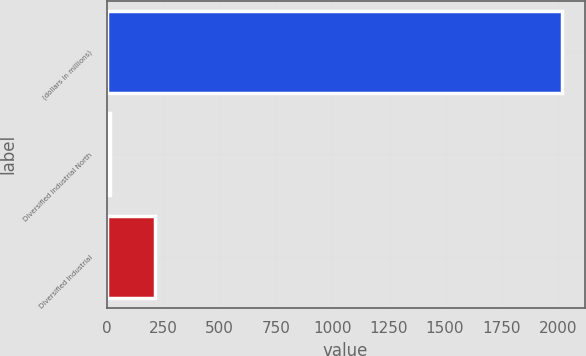Convert chart to OTSL. <chart><loc_0><loc_0><loc_500><loc_500><bar_chart><fcel>(dollars in millions)<fcel>Diversified Industrial North<fcel>Diversified Industrial<nl><fcel>2019<fcel>13<fcel>213.6<nl></chart> 